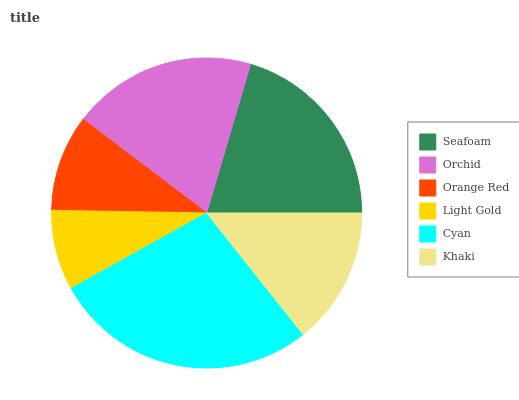Is Light Gold the minimum?
Answer yes or no. Yes. Is Cyan the maximum?
Answer yes or no. Yes. Is Orchid the minimum?
Answer yes or no. No. Is Orchid the maximum?
Answer yes or no. No. Is Seafoam greater than Orchid?
Answer yes or no. Yes. Is Orchid less than Seafoam?
Answer yes or no. Yes. Is Orchid greater than Seafoam?
Answer yes or no. No. Is Seafoam less than Orchid?
Answer yes or no. No. Is Orchid the high median?
Answer yes or no. Yes. Is Khaki the low median?
Answer yes or no. Yes. Is Orange Red the high median?
Answer yes or no. No. Is Light Gold the low median?
Answer yes or no. No. 